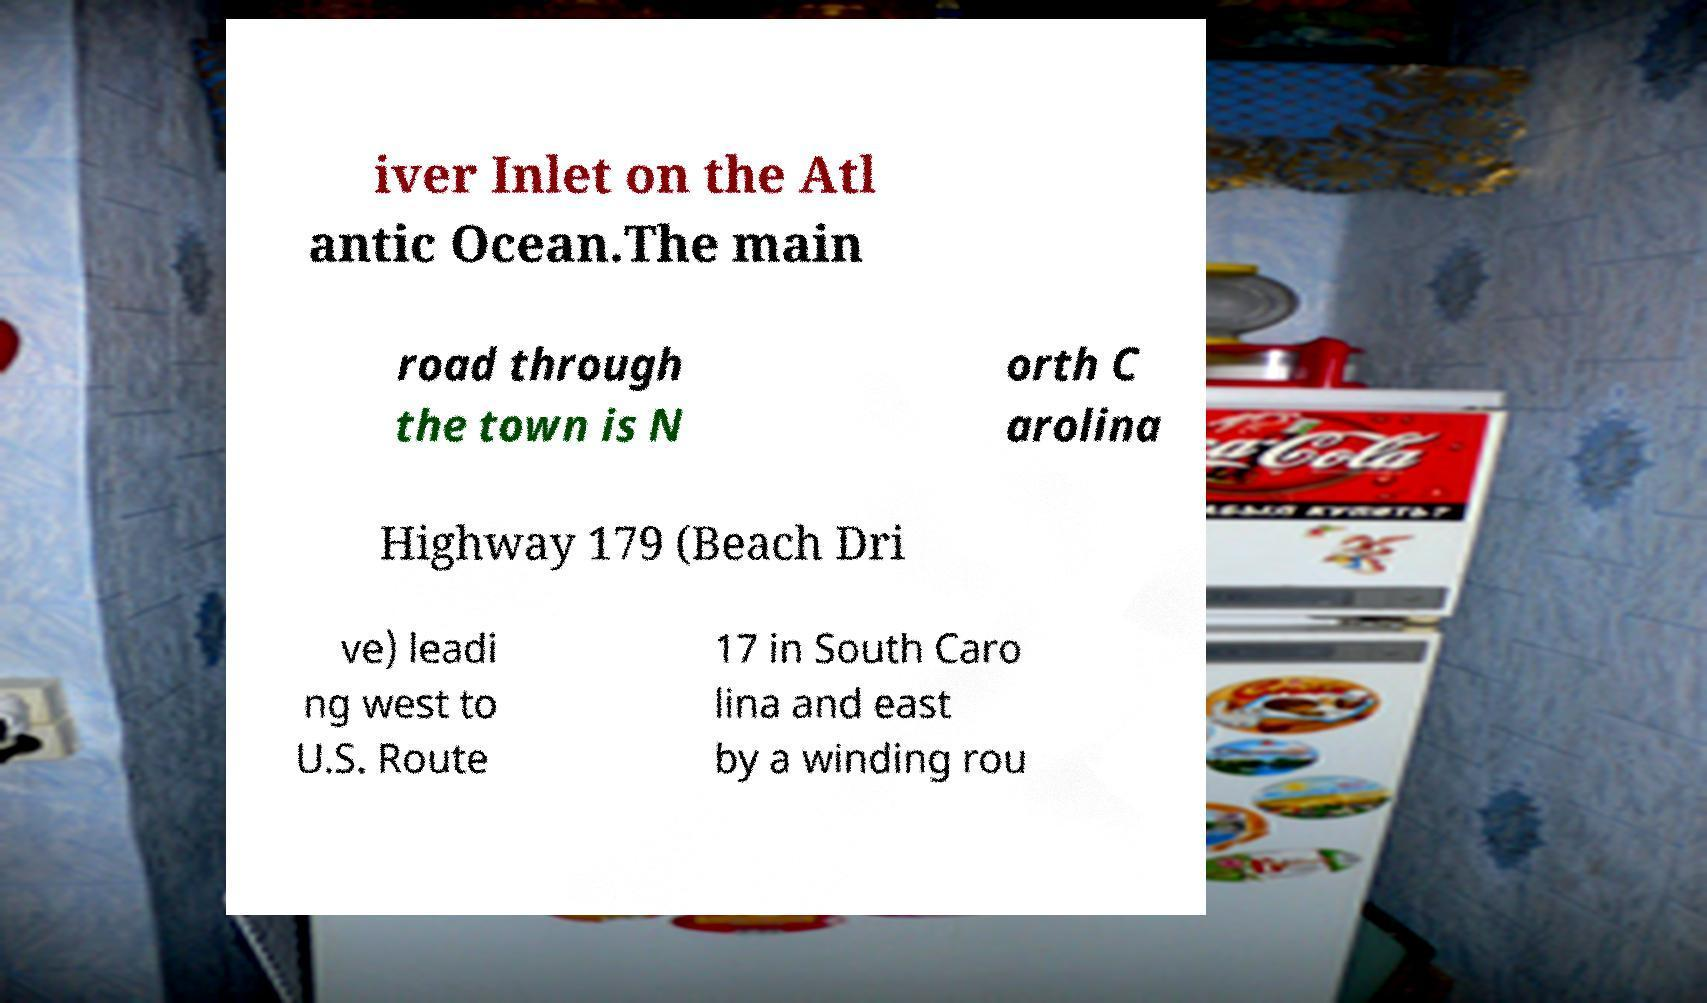Can you accurately transcribe the text from the provided image for me? iver Inlet on the Atl antic Ocean.The main road through the town is N orth C arolina Highway 179 (Beach Dri ve) leadi ng west to U.S. Route 17 in South Caro lina and east by a winding rou 